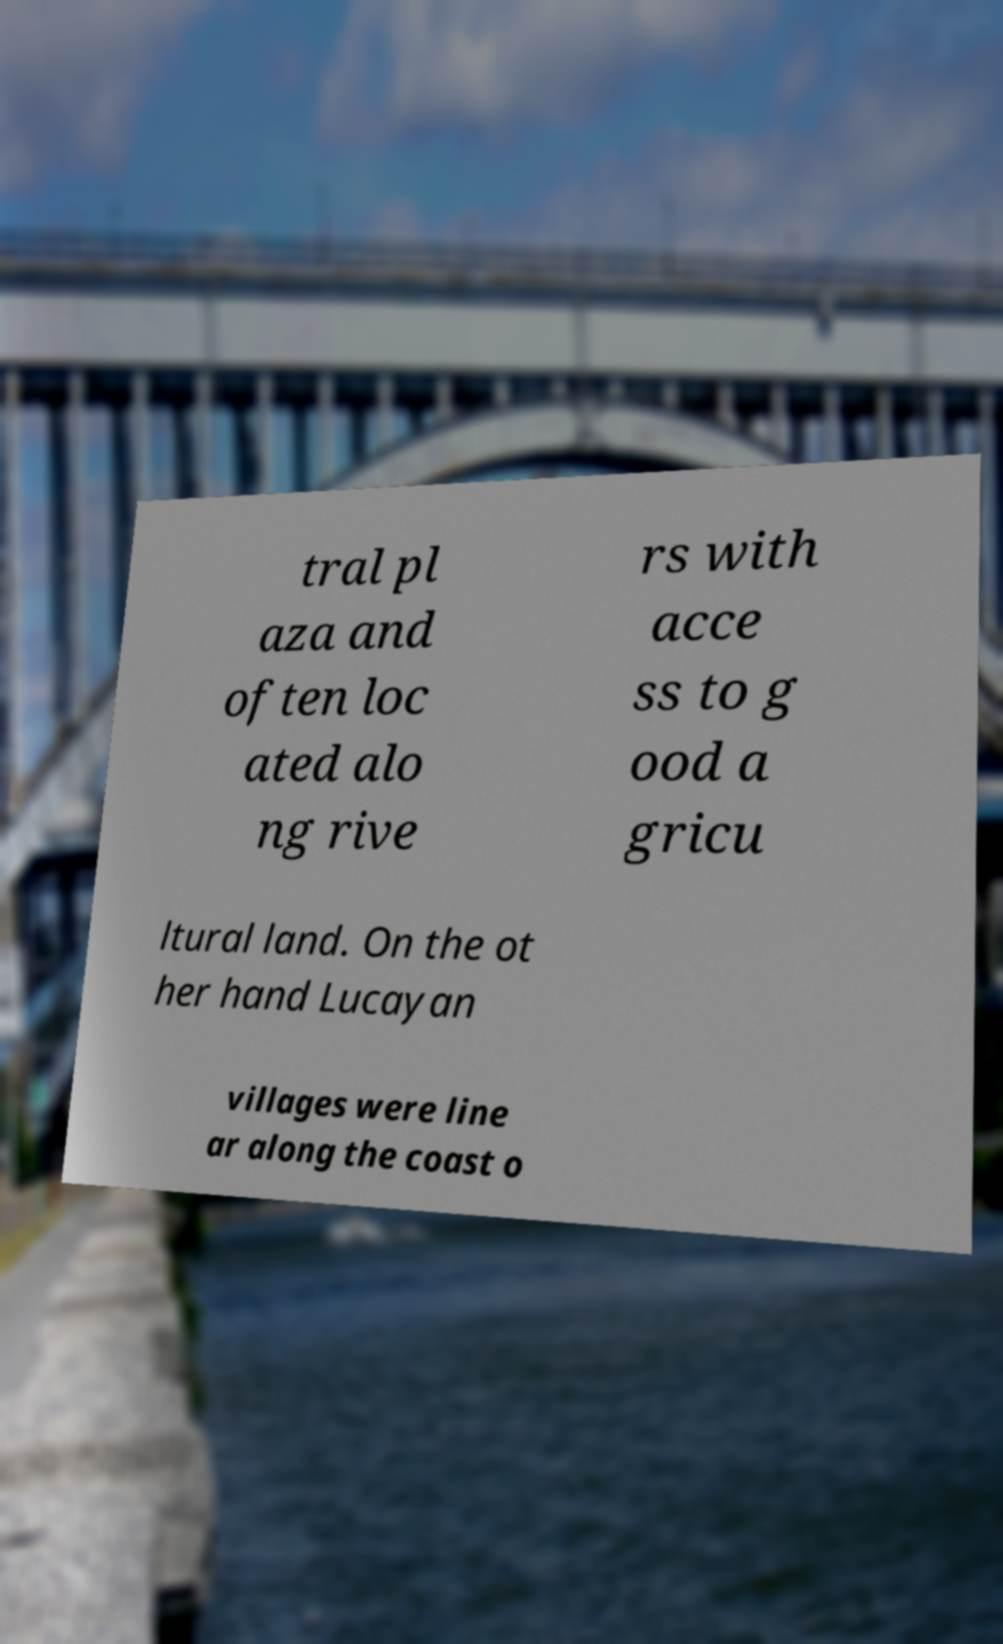Could you assist in decoding the text presented in this image and type it out clearly? tral pl aza and often loc ated alo ng rive rs with acce ss to g ood a gricu ltural land. On the ot her hand Lucayan villages were line ar along the coast o 